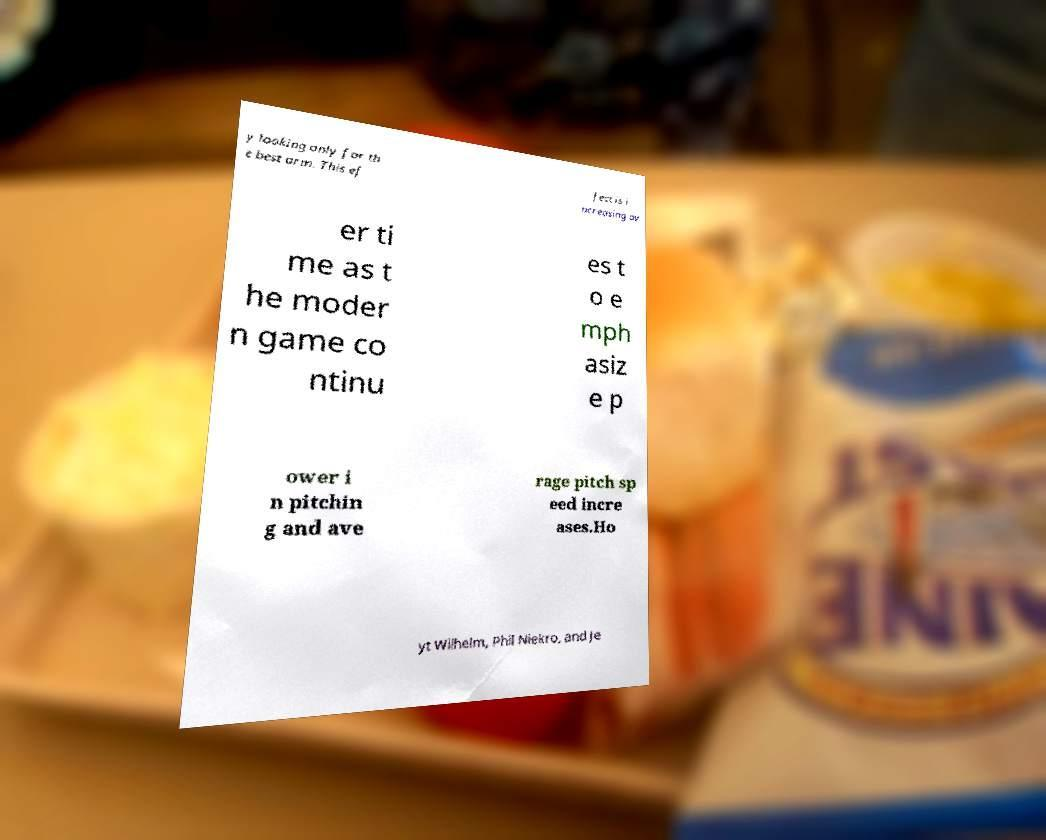Could you assist in decoding the text presented in this image and type it out clearly? y looking only for th e best arm. This ef fect is i ncreasing ov er ti me as t he moder n game co ntinu es t o e mph asiz e p ower i n pitchin g and ave rage pitch sp eed incre ases.Ho yt Wilhelm, Phil Niekro, and Je 